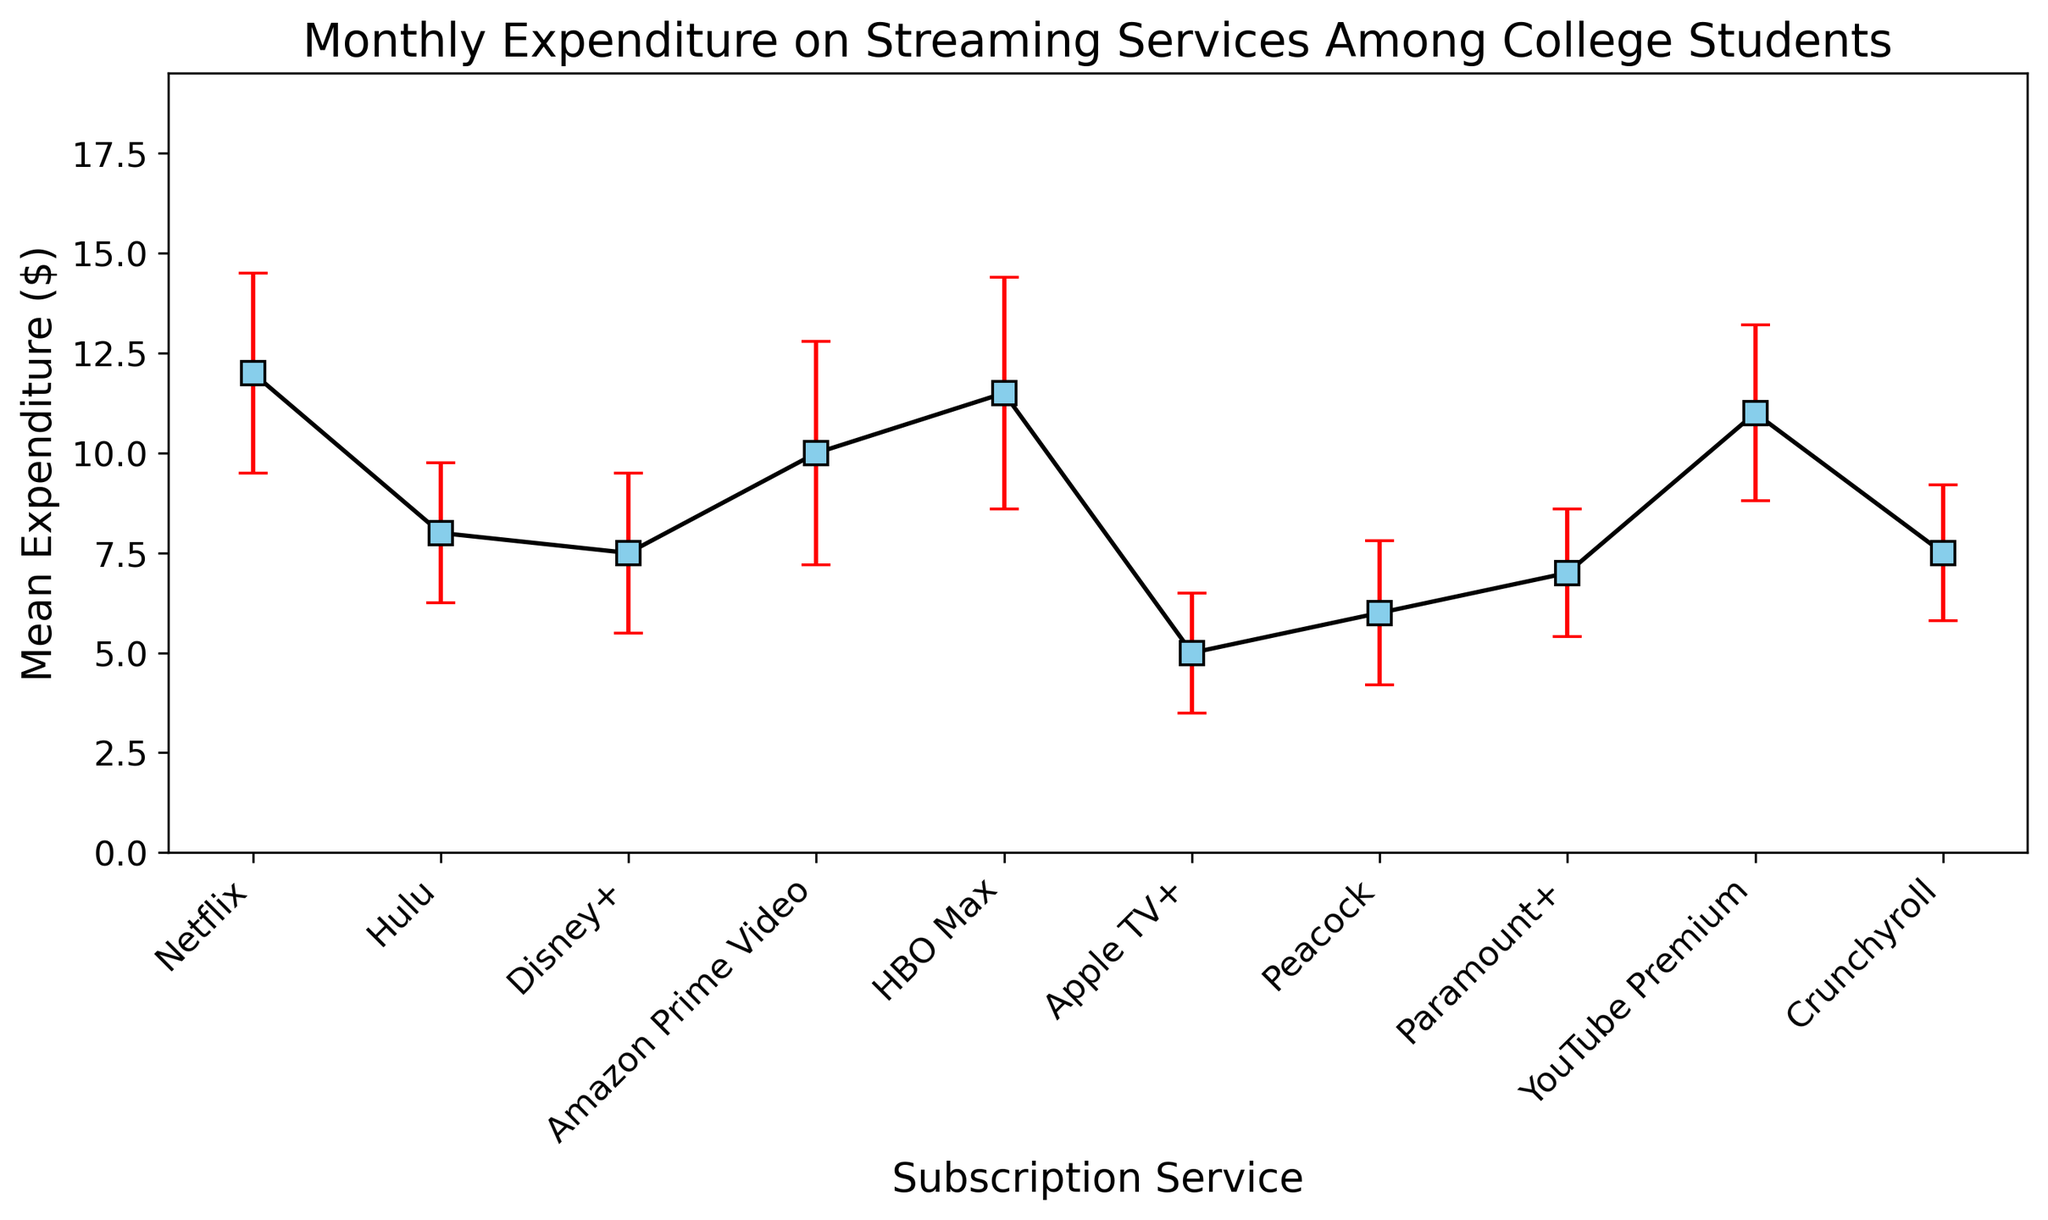What is the mean monthly expenditure on Netflix? Look at the figure and find the mean value represented by the height of the marker for Netflix.
Answer: 12.00 Which subscription service has the highest mean expenditure? Identify the tallest marker in the chart, signifying the highest mean expenditure.
Answer: Netflix How much more do college students spend on Amazon Prime Video than on Apple TV+? Subtract the mean expenditure for Apple TV+ from the mean expenditure for Amazon Prime Video. 10.00 - 5.00 = 5.00
Answer: 5.00 Which subscription service has the widest error bars and what does that indicate? Identify the service with the largest vertical span of the error bars. This indicates the greatest variability in expenditure.
Answer: HBO Max What is the sum of mean expenditures for Disney+ and HBO Max? Add the mean expenditures for Disney+ and HBO Max. 7.50 + 11.50 = 19.00
Answer: 19.00 Do college students spend more on average on Hulu or YouTube Premium? Compare the mean expenditures of Hulu and YouTube Premium. YouTube Premium has a higher mean expenditure.
Answer: YouTube Premium What is the average monthly expenditure across all streaming services? Sum all the mean expenditures and then divide by the number of services: (12.00 + 8.00 + 7.50 + 10.00 + 11.50 + 5.00 + 6.00 + 7.00 + 11.00 + 7.50) / 10 = 8.65
Answer: 8.65 Which two services have the closest mean expenditures and what is the difference? Find the two markers with the closest mean values by comparing the differences. Disney+ and Crunchyroll both have 7.50, so the difference is 0.00.
Answer: Disney+ and Crunchyroll; 0.00 What is the range of mean expenditures among all streaming services? Find the difference between the highest and lowest mean expenditures. 12.00 (Netflix) - 5.00 (Apple TV+) = 7.00
Answer: 7.00 